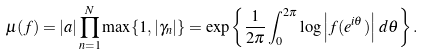<formula> <loc_0><loc_0><loc_500><loc_500>\mu ( f ) = | a | \prod _ { n = 1 } ^ { N } \max \{ 1 , | \gamma _ { n } | \} = \exp \left \{ \frac { 1 } { 2 \pi } \int _ { 0 } ^ { 2 \pi } \log \left | f ( e ^ { i \theta } ) \right | \, d \theta \right \} .</formula> 